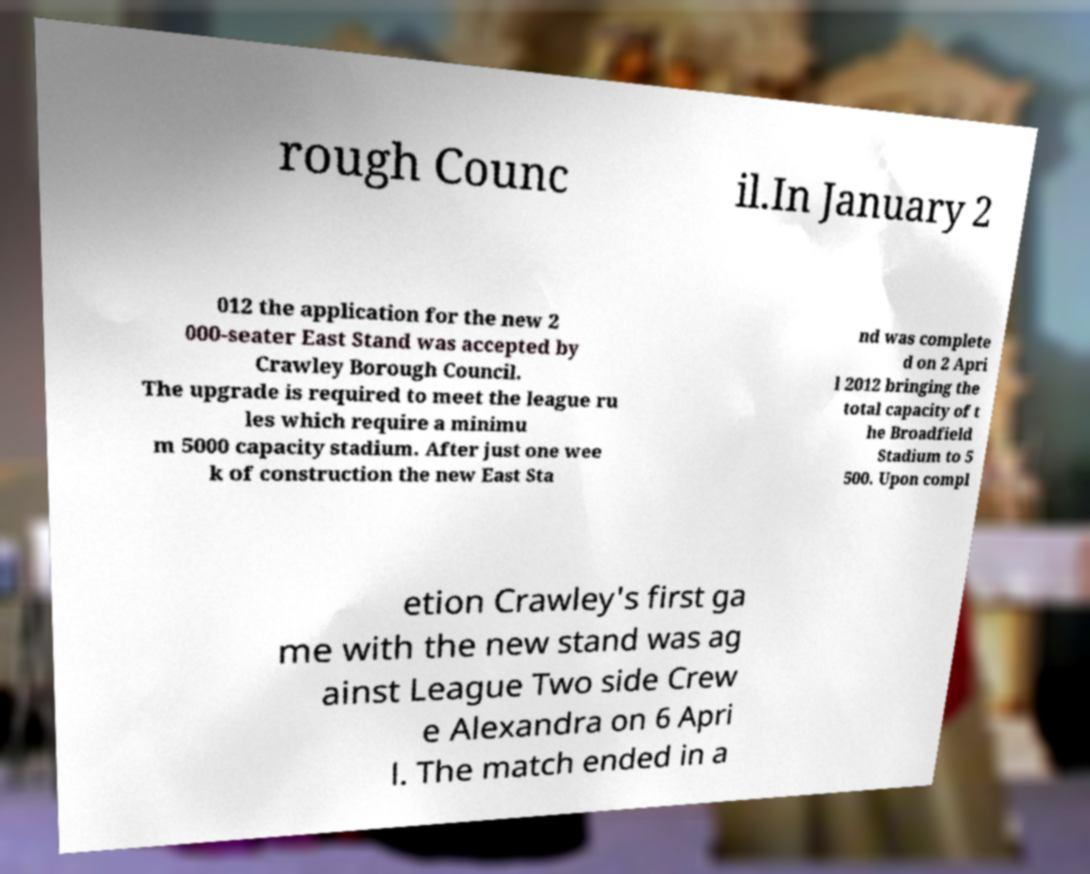Could you assist in decoding the text presented in this image and type it out clearly? rough Counc il.In January 2 012 the application for the new 2 000-seater East Stand was accepted by Crawley Borough Council. The upgrade is required to meet the league ru les which require a minimu m 5000 capacity stadium. After just one wee k of construction the new East Sta nd was complete d on 2 Apri l 2012 bringing the total capacity of t he Broadfield Stadium to 5 500. Upon compl etion Crawley's first ga me with the new stand was ag ainst League Two side Crew e Alexandra on 6 Apri l. The match ended in a 